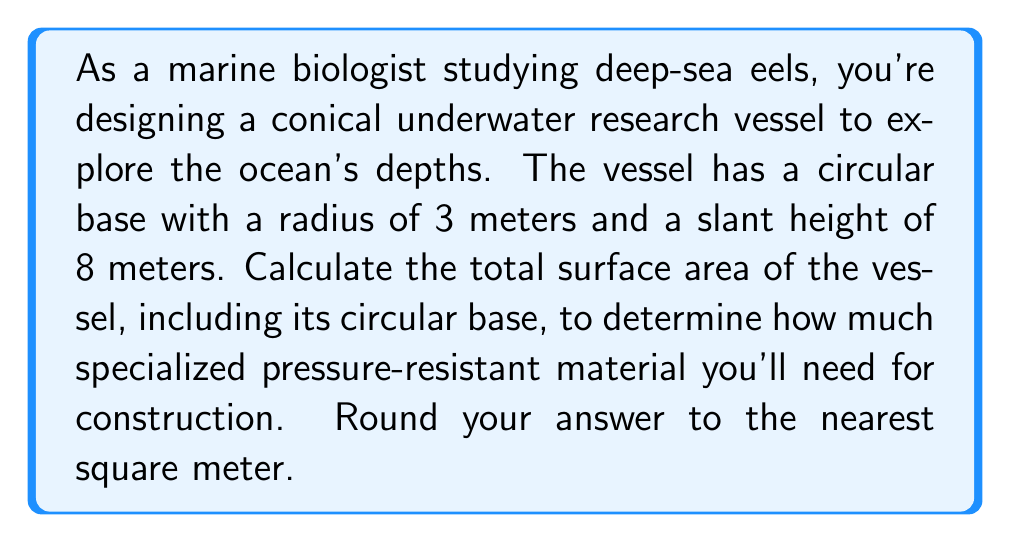Help me with this question. To solve this problem, we need to calculate the surface area of a cone, which consists of the lateral surface area (the curved part) and the area of the circular base.

1. Let's define our variables:
   $r$ = radius of the base = 3 meters
   $s$ = slant height = 8 meters

2. The formula for the surface area of a cone is:
   $$A = \pi r^2 + \pi rs$$
   where $\pi r^2$ is the area of the circular base and $\pi rs$ is the lateral surface area.

3. Let's calculate each part:
   
   Area of the base: $\pi r^2 = \pi (3^2) = 9\pi$

   Lateral surface area: $\pi rs = \pi(3)(8) = 24\pi$

4. Now, let's add these together:
   $$A = 9\pi + 24\pi = 33\pi$$

5. Calculate the final value:
   $$A = 33\pi \approx 103.67 \text{ square meters}$$

6. Rounding to the nearest square meter:
   $$A \approx 104 \text{ square meters}$$

[asy]
import geometry;

size(200);

pair O=(0,0);
pair A=(3,0);
pair B=(0,8);

draw(O--A--B--O);
draw(arc(O,3,0,360));

label("3 m",A/2,S);
label("8 m",(O+B)/2,NW);

draw(O--(3,8),dashed);
[/asy]
Answer: 104 square meters 